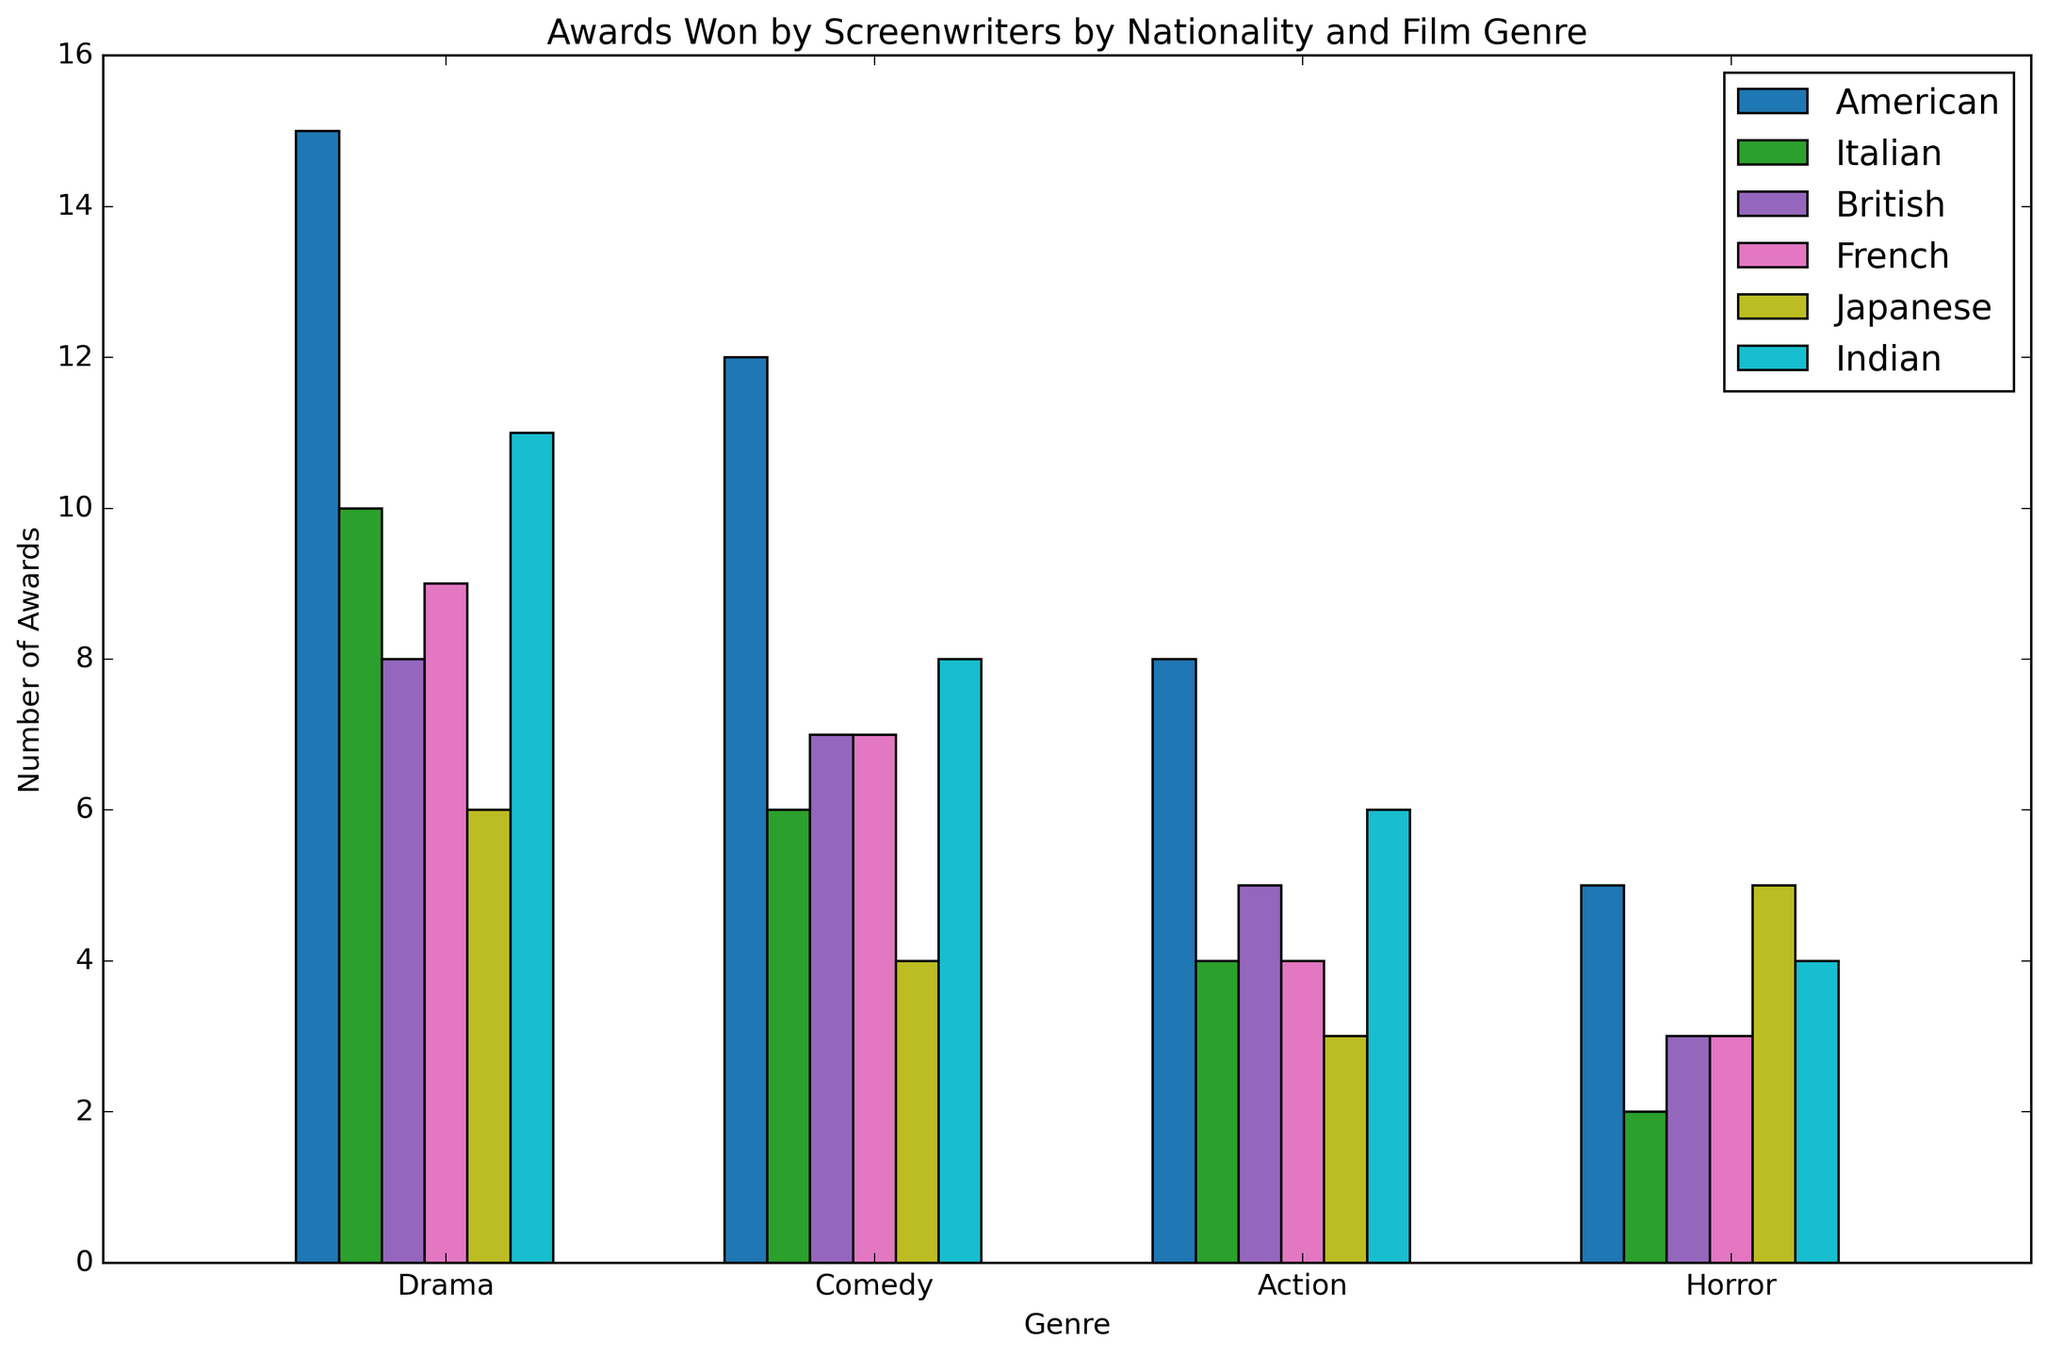Which nationality has won the most awards in Comedy? To find this, look at the height of the bars for Comedy genre across all nationalities and identify the highest one. The tallest bar for Comedy belongs to the American nationality.
Answer: American What is the total number of awards won by Japanese screenwriters across all genres? Sum the number of awards for Japanese screenwriters for each genre: Drama (6) + Comedy (4) + Action (3) + Horror (5). The total is 6 + 4 + 3 + 5 = 18.
Answer: 18 Which genre has the widest range of awards (difference between highest and lowest) across all nationalities? Calculate the range for each genre. For Drama: highest (American, 15) - lowest (Japanese, 6) = 9. Comedy: highest (American, 12) - lowest (Japanese, 4) = 8. Action: highest (American, 8) - lowest (Japanese, 3) = 5. Horror: highest (American & Japanese, 5) - lowest (Italian & British & French, 2) = 3. The genre with the widest range is Drama.
Answer: Drama How many more awards have American screenwriters won in Action than French screenwriters? Subtract the number of awards for French in Action (4) from American in Action (8). The difference is 8 - 4 = 4.
Answer: 4 Which nationality has won the fewest awards in Drama? Look at the bars corresponding to the Drama genre for all nationalities and identify the shortest one. The shortest bar for Drama is for Japanese screenwriters.
Answer: Japanese Are there any genres in which all nationalities have won the same number of awards? Visually inspect each genre to see if the bars are all the same height across all nationalities. None of the genres have bars of equal height, indicating no genre has the same number of awards across all nationalities.
Answer: No Between British and Italian screenwriters, who has won more awards in Horror? Compare the height of the bars for Horror for British (3) and Italian (2). The British screenwriters have won more awards in Horror.
Answer: British What is the average number of awards won by American screenwriters per genre? Sum the number of awards for each genre for American screenwriters: 15 (Drama) + 12 (Comedy) + 8 (Action) + 5 (Horror) = 40. There are 4 genres, so the average is 40 / 4 = 10.
Answer: 10 How many awards in total have Indian screenwriters won in genres other than Drama? Sum the number of awards for Indian screenwriters in Comedy (8), Action (6), and Horror (4). The total is 8 + 6 + 4 = 18.
Answer: 18 